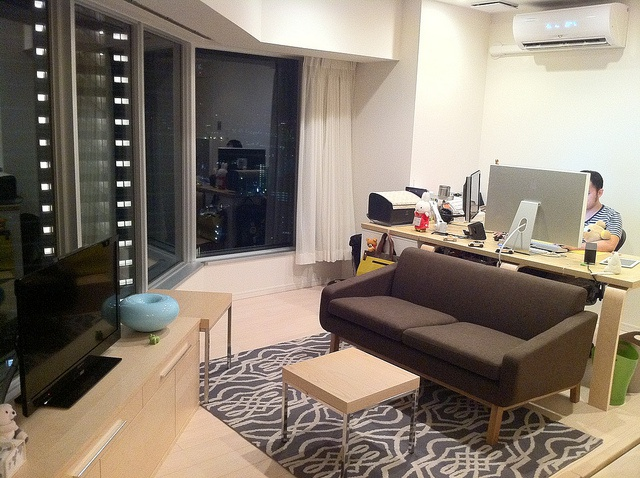Describe the objects in this image and their specific colors. I can see couch in black, gray, and maroon tones, tv in black and tan tones, tv in black, darkgray, gray, beige, and lightgray tones, dining table in black, khaki, gray, beige, and tan tones, and bowl in black, darkgray, gray, and lightblue tones in this image. 